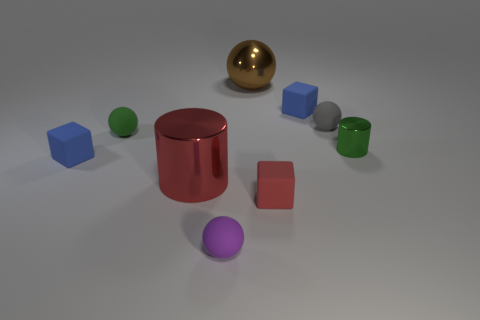Add 1 red metallic things. How many objects exist? 10 Subtract all blocks. How many objects are left? 6 Subtract 0 yellow cylinders. How many objects are left? 9 Subtract all big green matte cylinders. Subtract all matte things. How many objects are left? 3 Add 1 tiny metal cylinders. How many tiny metal cylinders are left? 2 Add 6 tiny gray rubber balls. How many tiny gray rubber balls exist? 7 